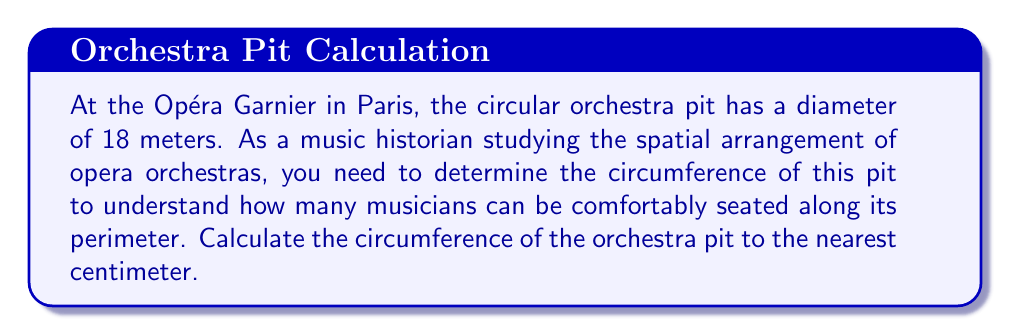Solve this math problem. To solve this problem, we'll use the formula for the circumference of a circle:

$$C = \pi d$$

Where:
$C$ = circumference
$\pi$ = pi (approximately 3.14159)
$d$ = diameter

Given:
- The diameter of the orchestra pit is 18 meters.

Step 1: Substitute the given diameter into the formula.
$$C = \pi \times 18$$

Step 2: Calculate the result.
$$C \approx 3.14159 \times 18 \approx 56.54862 \text{ meters}$$

Step 3: Round the result to the nearest centimeter (0.01 meter).
$$C \approx 56.55 \text{ meters}$$

This calculation gives us the approximate circumference of the circular orchestra pit at the Opéra Garnier, which can help in determining the seating arrangement for musicians.

[asy]
unitsize(10cm);
draw(circle((0,0),1), blue);
draw((-1,0)--(1,0), blue+dashed);
label("18 m", (0,-1.1), blue);
label("Circumference ≈ 56.55 m", (0,1.2), blue);
[/asy]
Answer: The circumference of the orchestra pit is approximately 56.55 meters. 